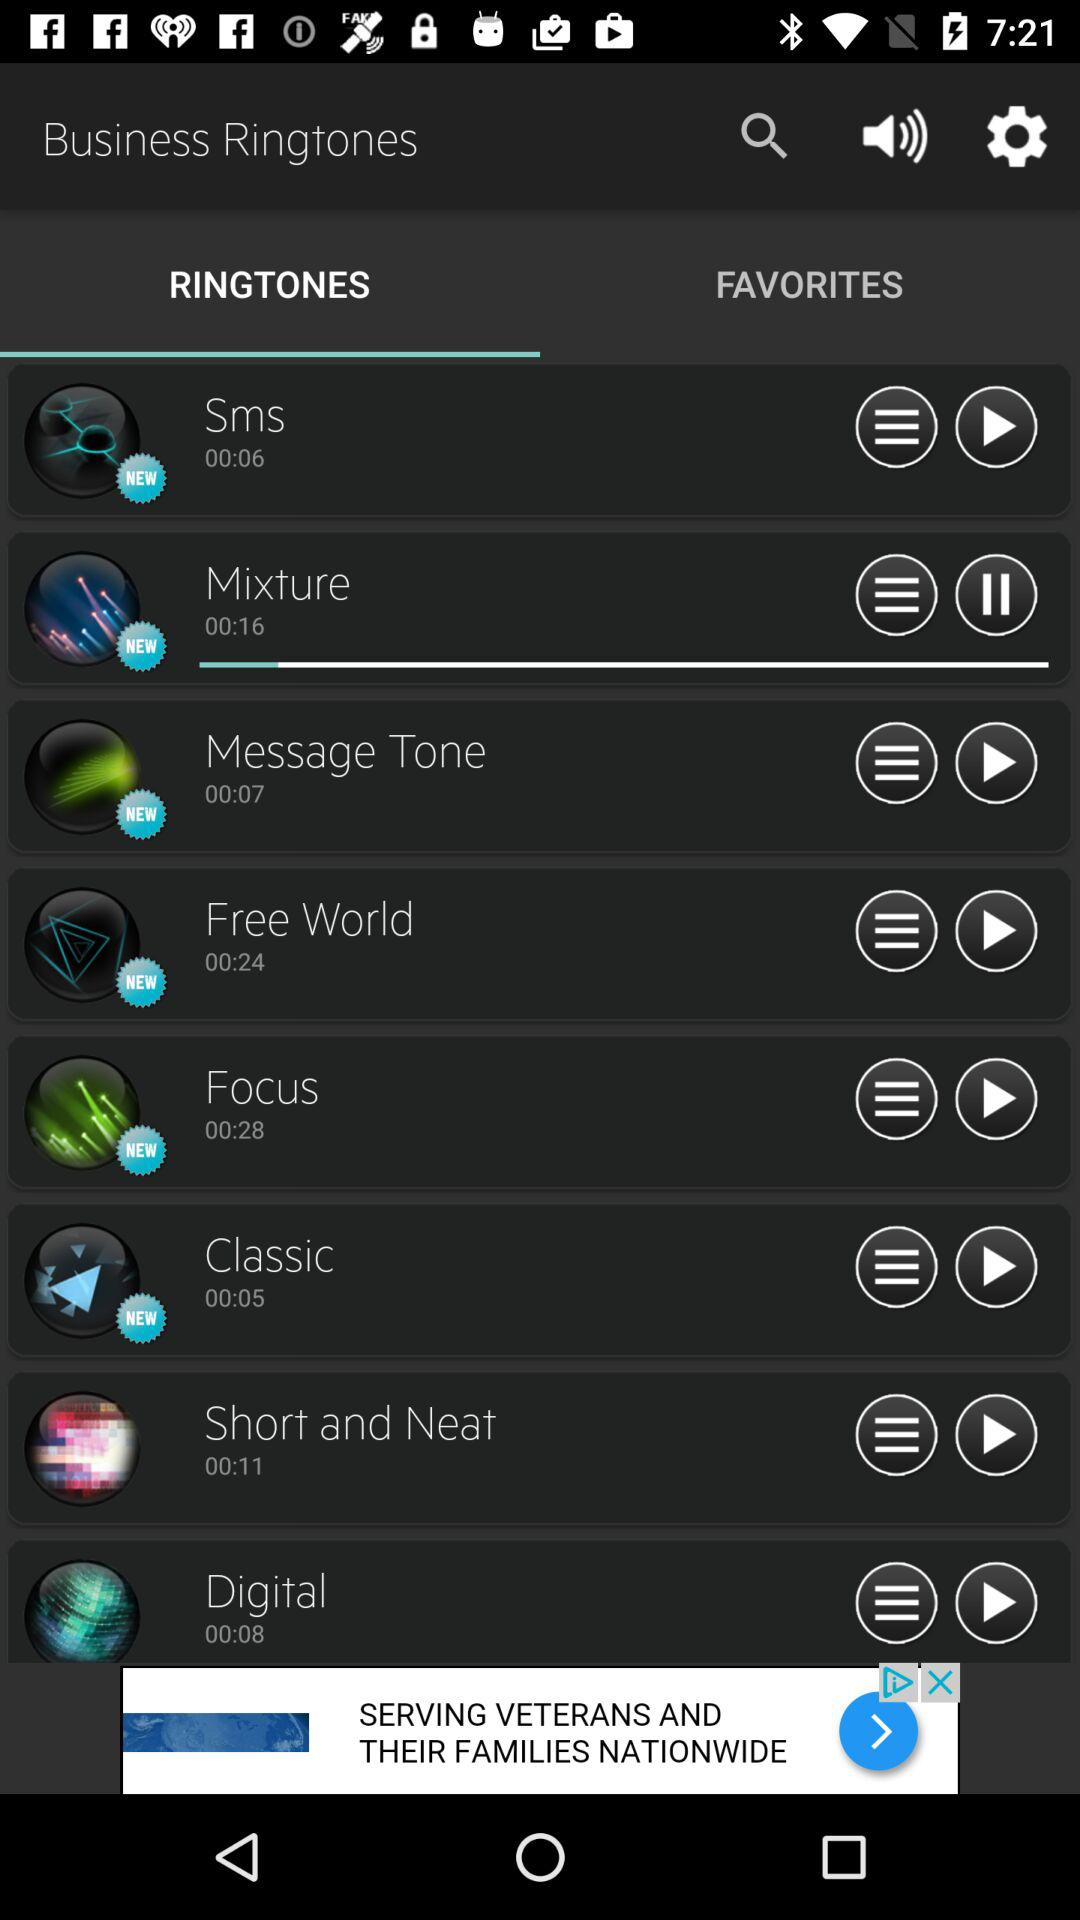What is the duration of the Short and Neat ringtone? The duration of the Short and Neat ringtone is 11 seconds. 